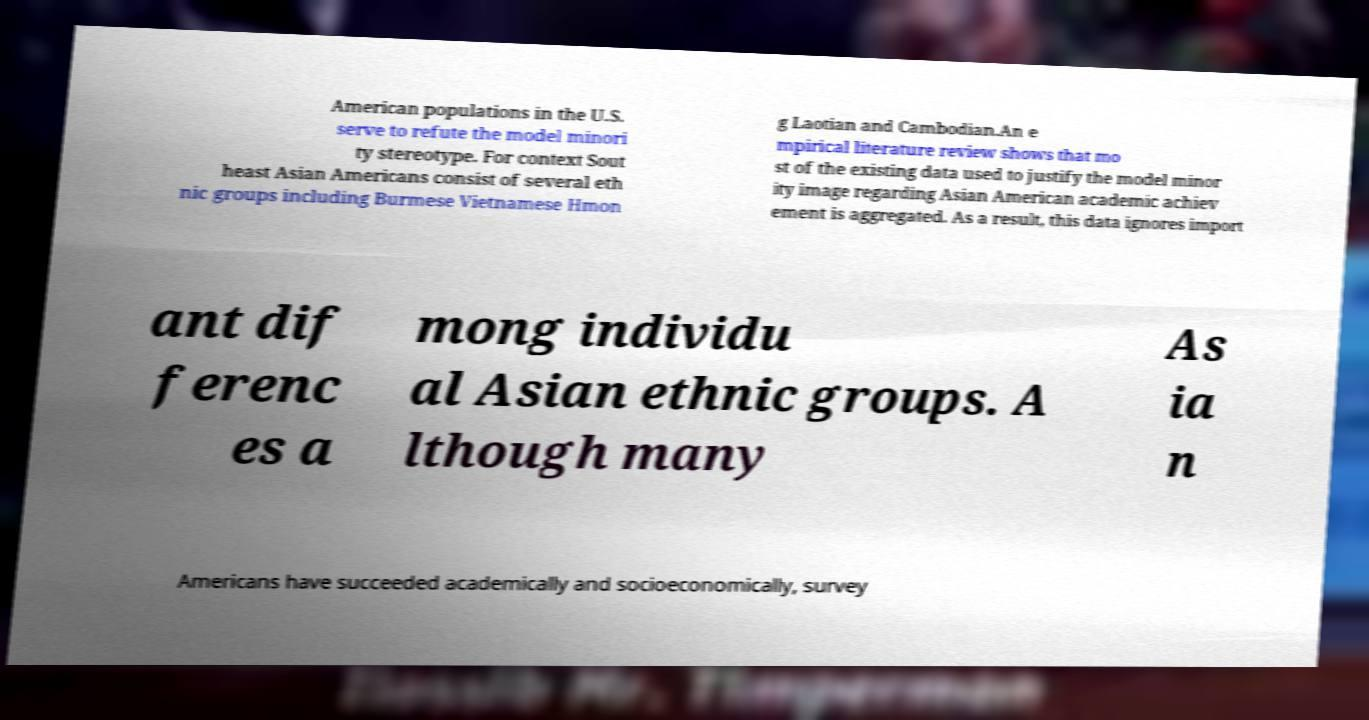I need the written content from this picture converted into text. Can you do that? American populations in the U.S. serve to refute the model minori ty stereotype. For context Sout heast Asian Americans consist of several eth nic groups including Burmese Vietnamese Hmon g Laotian and Cambodian.An e mpirical literature review shows that mo st of the existing data used to justify the model minor ity image regarding Asian American academic achiev ement is aggregated. As a result, this data ignores import ant dif ferenc es a mong individu al Asian ethnic groups. A lthough many As ia n Americans have succeeded academically and socioeconomically, survey 